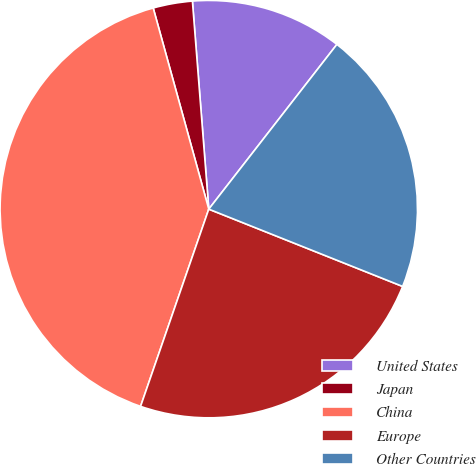<chart> <loc_0><loc_0><loc_500><loc_500><pie_chart><fcel>United States<fcel>Japan<fcel>China<fcel>Europe<fcel>Other Countries<nl><fcel>11.77%<fcel>3.04%<fcel>40.41%<fcel>24.26%<fcel>20.52%<nl></chart> 